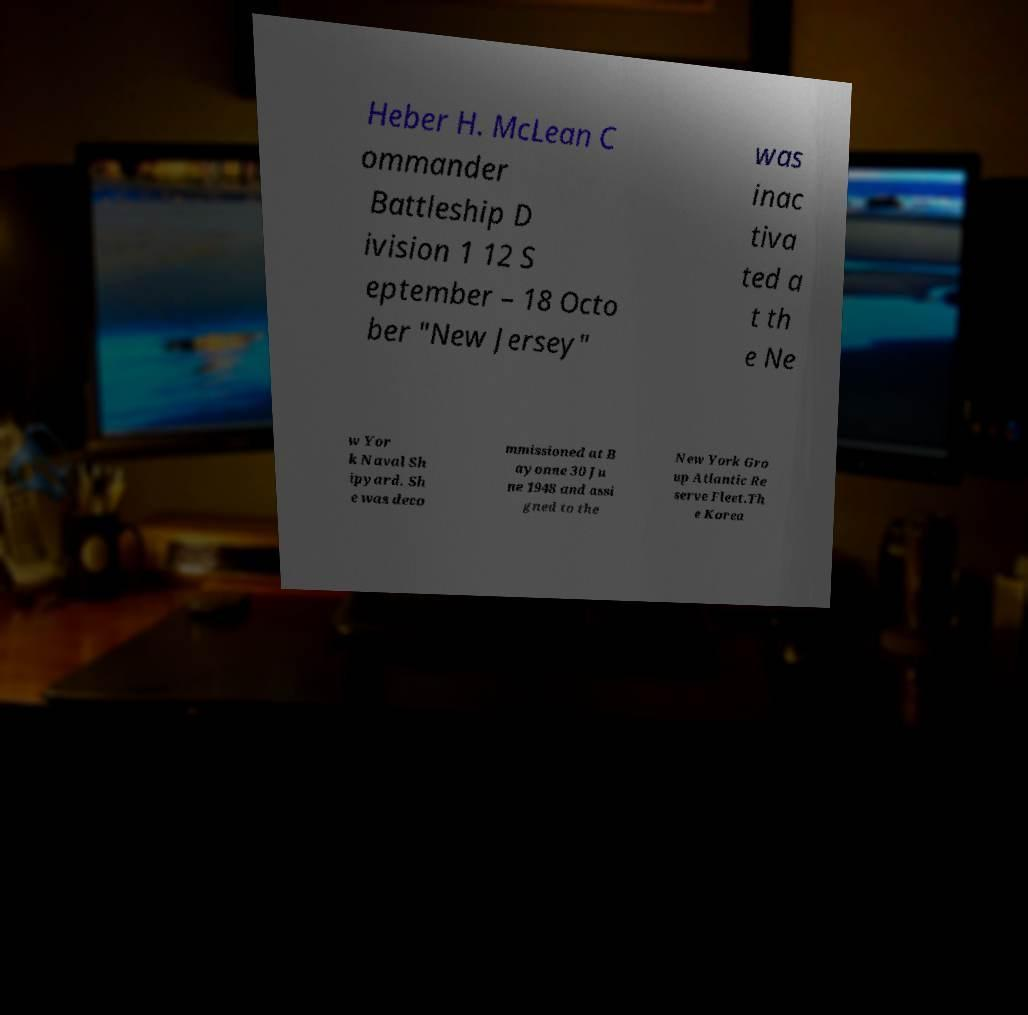There's text embedded in this image that I need extracted. Can you transcribe it verbatim? Heber H. McLean C ommander Battleship D ivision 1 12 S eptember – 18 Octo ber "New Jersey" was inac tiva ted a t th e Ne w Yor k Naval Sh ipyard. Sh e was deco mmissioned at B ayonne 30 Ju ne 1948 and assi gned to the New York Gro up Atlantic Re serve Fleet.Th e Korea 